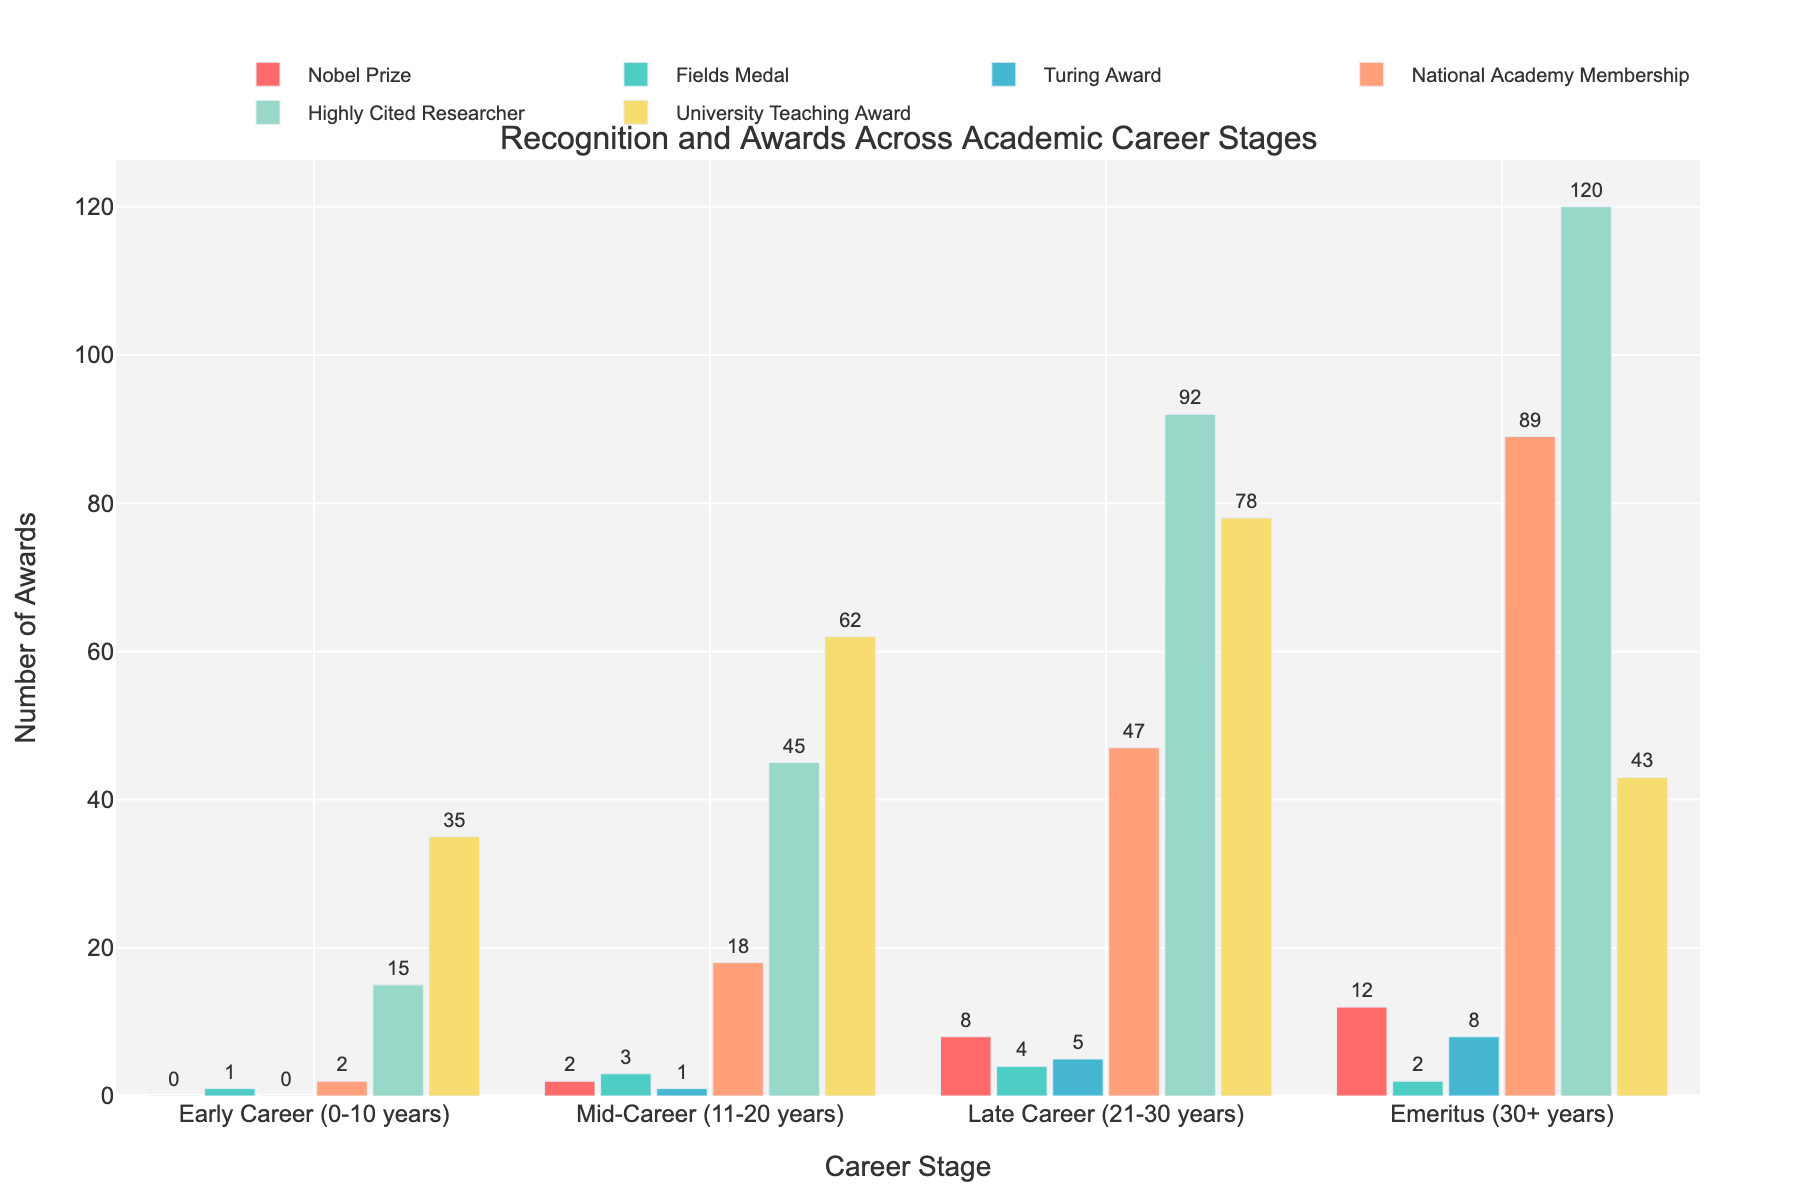How many Nobel Prizes are awarded in the late career stage? In the late career stage, the bar representing Nobel Prizes reaches up to 8. Thus, 8 Nobel Prizes have been awarded in the late career stage.
Answer: 8 Which career stage has the highest number of National Academy Memberships? Among all bars representing National Academy Memberships across different career stages, the bar in the Emeritus stage is the highest, indicating it has the most National Academy Memberships.
Answer: Emeritus (30+ years) Compare the number of Fields Medals between early career and mid-career stages. Which stage has more, and by how many? The early career stage has 1 Fields Medal, while the mid-career stage has 3 Fields Medals. Thus, the mid-career stage has 2 more Fields Medals than the early career stage.
Answer: Mid-Career (11-20 years) by 2 What's the combined total number of Highly Cited Researchers in mid-career and late career stages? In the mid-career stage, there are 45 Highly Cited Researchers, and in the late career stage, there are 92. Adding them together, 45 + 92 = 137.
Answer: 137 How does the number of Turing Awards change from mid-career to Emeritus stage? The number of Turing Awards in the mid-career stage is 1, and in the Emeritus stage, it is 8. The increase in Turing Awards from mid-career to Emeritus stage can be calculated as 8 - 1 = 7.
Answer: Increased by 7 Which award has the most uniform distribution across the career stages? By visually comparing the heights of the bars for each award across all career stages, the University Teaching Award appears to have the most balanced distribution, with no extreme highs or lows.
Answer: University Teaching Award Identify the career stage with the fewest total awards received. Summing up the values of all awards in each career stage: 
- Early Career: 0+1+0+2+15+35 = 53
- Mid-Career: 2+3+1+18+45+62 = 131
- Late Career: 8+4+5+47+92+78 = 234
- Emeritus: 12+2+8+89+120+43 = 274 
The Early Career stage has the fewest total awards.
Answer: Early Career (0-10 years) What is the difference between the number of University Teaching Awards in the mid-career and the late career stages? For the mid-career stage, there are 62 University Teaching Awards, and for the late career stage, there are 78. The difference is 78 - 62 = 16.
Answer: 16 Which career stage sees the highest increase in National Academy Memberships compared to its preceding stage? Calculating the increases:
- Early to Mid-Career: 18 - 2 = 16
- Mid-Career to Late Career: 47 - 18 = 29
- Late Career to Emeritus: 89 - 47 = 42
The jump from the Late Career stage to the Emeritus stage is the largest, with an increase of 42.
Answer: Late Career to Emeritus (42) 